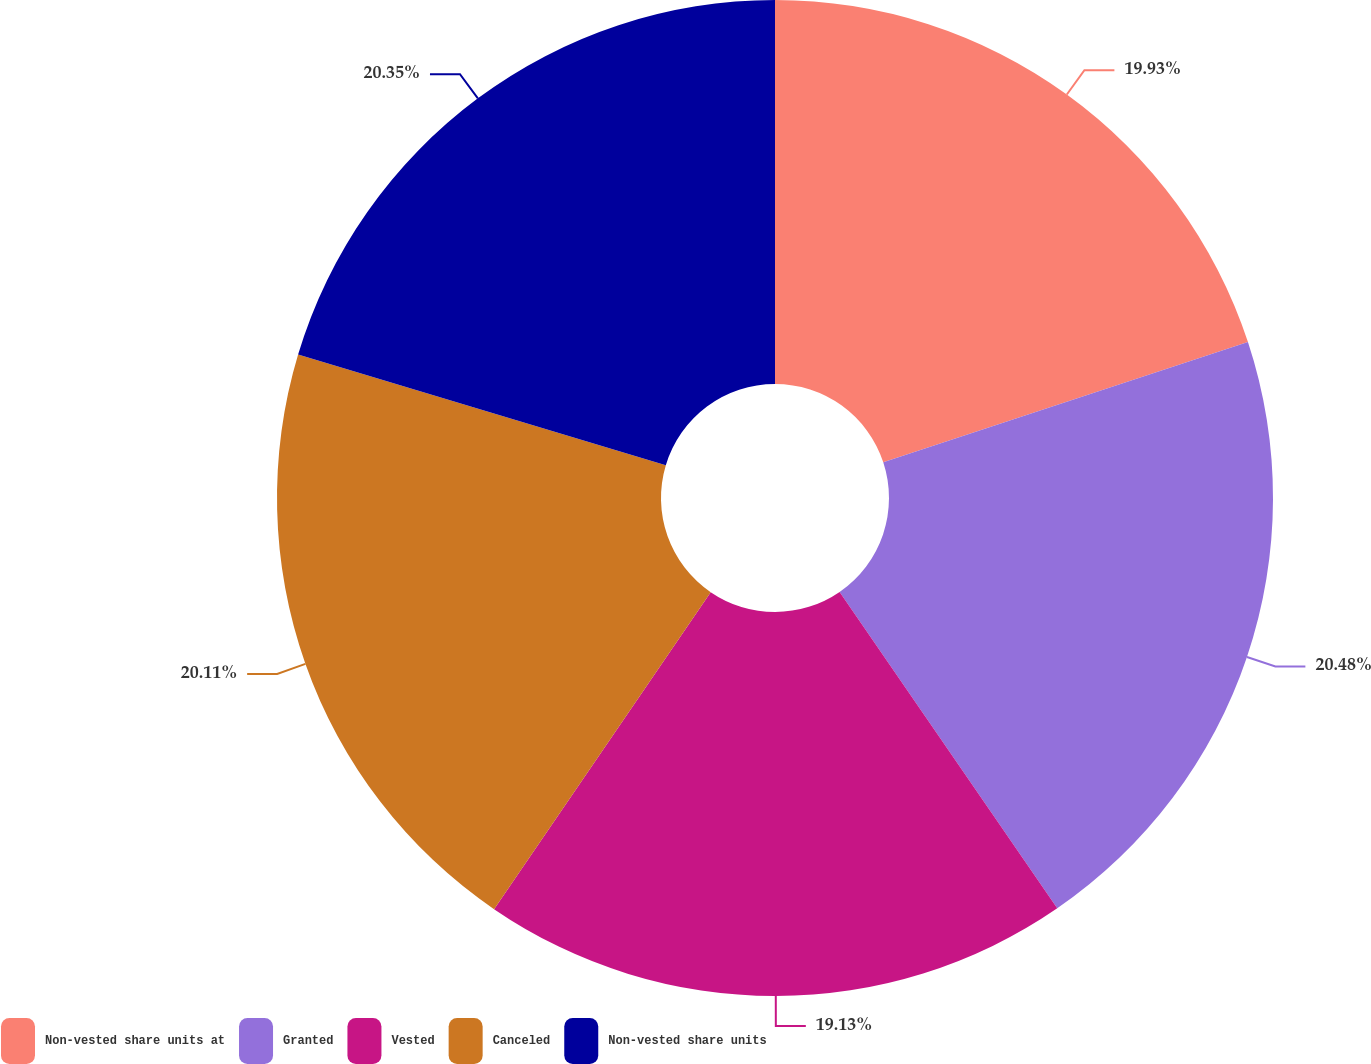<chart> <loc_0><loc_0><loc_500><loc_500><pie_chart><fcel>Non-vested share units at<fcel>Granted<fcel>Vested<fcel>Canceled<fcel>Non-vested share units<nl><fcel>19.93%<fcel>20.48%<fcel>19.13%<fcel>20.11%<fcel>20.35%<nl></chart> 